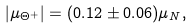Convert formula to latex. <formula><loc_0><loc_0><loc_500><loc_500>| \mu _ { \Theta ^ { + } } | = ( 0 . 1 2 \pm 0 . 0 6 ) \mu _ { N } ,</formula> 